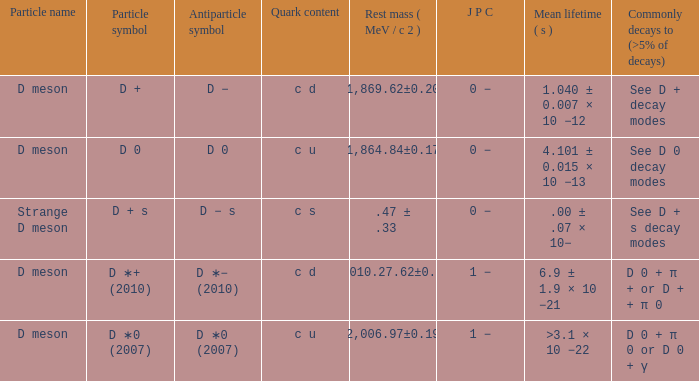What jpc has a common decay mode (>5% of decays) of d0 + π0 or d0 + γ? 1 −. 